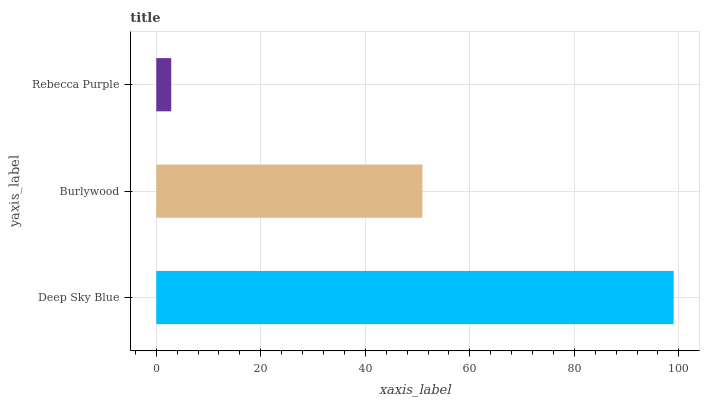Is Rebecca Purple the minimum?
Answer yes or no. Yes. Is Deep Sky Blue the maximum?
Answer yes or no. Yes. Is Burlywood the minimum?
Answer yes or no. No. Is Burlywood the maximum?
Answer yes or no. No. Is Deep Sky Blue greater than Burlywood?
Answer yes or no. Yes. Is Burlywood less than Deep Sky Blue?
Answer yes or no. Yes. Is Burlywood greater than Deep Sky Blue?
Answer yes or no. No. Is Deep Sky Blue less than Burlywood?
Answer yes or no. No. Is Burlywood the high median?
Answer yes or no. Yes. Is Burlywood the low median?
Answer yes or no. Yes. Is Deep Sky Blue the high median?
Answer yes or no. No. Is Rebecca Purple the low median?
Answer yes or no. No. 